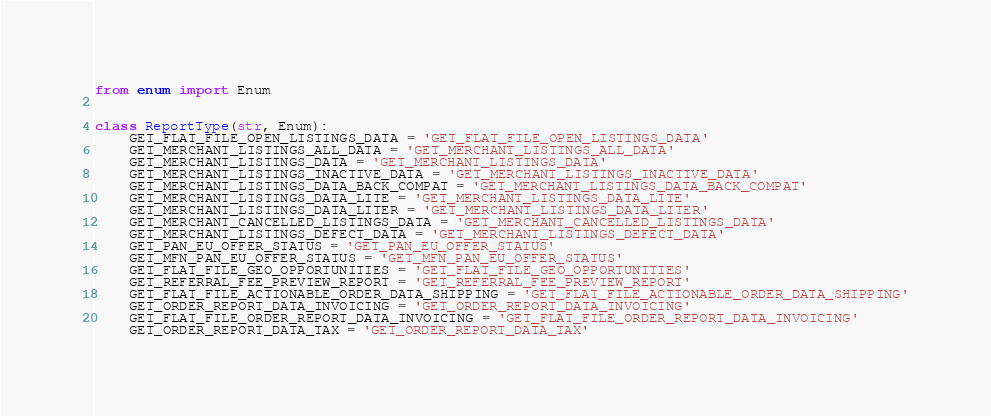Convert code to text. <code><loc_0><loc_0><loc_500><loc_500><_Python_>from enum import Enum


class ReportType(str, Enum):
    GET_FLAT_FILE_OPEN_LISTINGS_DATA = 'GET_FLAT_FILE_OPEN_LISTINGS_DATA'
    GET_MERCHANT_LISTINGS_ALL_DATA = 'GET_MERCHANT_LISTINGS_ALL_DATA'
    GET_MERCHANT_LISTINGS_DATA = 'GET_MERCHANT_LISTINGS_DATA'
    GET_MERCHANT_LISTINGS_INACTIVE_DATA = 'GET_MERCHANT_LISTINGS_INACTIVE_DATA'
    GET_MERCHANT_LISTINGS_DATA_BACK_COMPAT = 'GET_MERCHANT_LISTINGS_DATA_BACK_COMPAT'
    GET_MERCHANT_LISTINGS_DATA_LITE = 'GET_MERCHANT_LISTINGS_DATA_LITE'
    GET_MERCHANT_LISTINGS_DATA_LITER = 'GET_MERCHANT_LISTINGS_DATA_LITER'
    GET_MERCHANT_CANCELLED_LISTINGS_DATA = 'GET_MERCHANT_CANCELLED_LISTINGS_DATA'
    GET_MERCHANT_LISTINGS_DEFECT_DATA = 'GET_MERCHANT_LISTINGS_DEFECT_DATA'
    GET_PAN_EU_OFFER_STATUS = 'GET_PAN_EU_OFFER_STATUS'
    GET_MFN_PAN_EU_OFFER_STATUS = 'GET_MFN_PAN_EU_OFFER_STATUS'
    GET_FLAT_FILE_GEO_OPPORTUNITIES = 'GET_FLAT_FILE_GEO_OPPORTUNITIES'
    GET_REFERRAL_FEE_PREVIEW_REPORT = 'GET_REFERRAL_FEE_PREVIEW_REPORT'
    GET_FLAT_FILE_ACTIONABLE_ORDER_DATA_SHIPPING = 'GET_FLAT_FILE_ACTIONABLE_ORDER_DATA_SHIPPING'
    GET_ORDER_REPORT_DATA_INVOICING = 'GET_ORDER_REPORT_DATA_INVOICING'
    GET_FLAT_FILE_ORDER_REPORT_DATA_INVOICING = 'GET_FLAT_FILE_ORDER_REPORT_DATA_INVOICING'
    GET_ORDER_REPORT_DATA_TAX = 'GET_ORDER_REPORT_DATA_TAX'</code> 